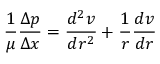Convert formula to latex. <formula><loc_0><loc_0><loc_500><loc_500>{ \frac { 1 } { \mu } } { \frac { \Delta p } { \Delta x } } = { \frac { d ^ { 2 } v } { d r ^ { 2 } } } + { \frac { 1 } { r } } { \frac { d v } { d r } }</formula> 